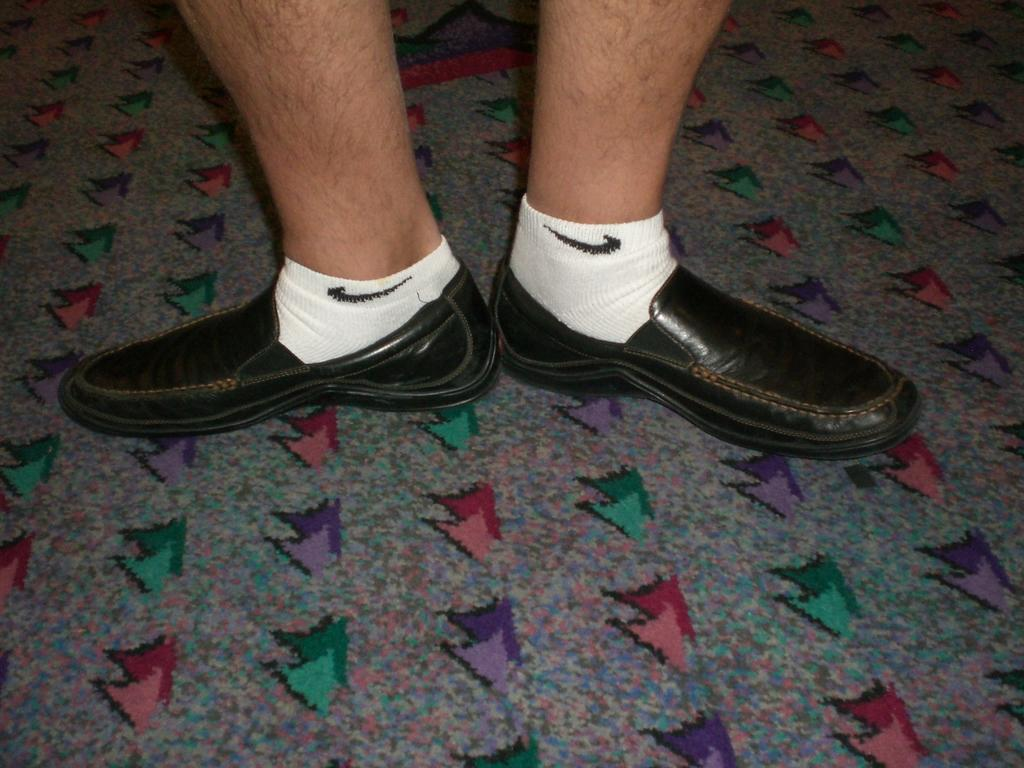What body part is visible in the image? There is a person's legs in the image. What type of footwear is the person wearing? The person is wearing shoes. Are there any additional layers of clothing on the person's feet? Yes, the person is wearing socks. Reasoning: Let' Let's think step by step in order to produce the conversation. We start by identifying the main subject in the image, which is the person's legs. Then, we expand the conversation to include details about the person's footwear and any additional layers of clothing. Each question is designed to elicit a specific detail about the image that is known from the provided facts. Absurd Question/Answer: What thought is the person having while holding the spark and stick in the image? There is no mention of a spark, stick, or thought in the image; it only shows a person's legs with shoes and socks. 